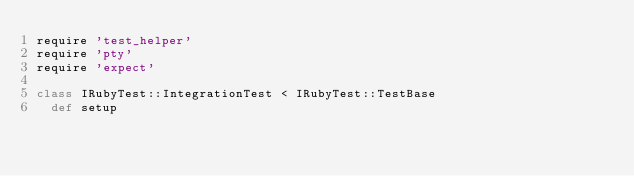Convert code to text. <code><loc_0><loc_0><loc_500><loc_500><_Ruby_>require 'test_helper'
require 'pty'
require 'expect'

class IRubyTest::IntegrationTest < IRubyTest::TestBase
  def setup</code> 